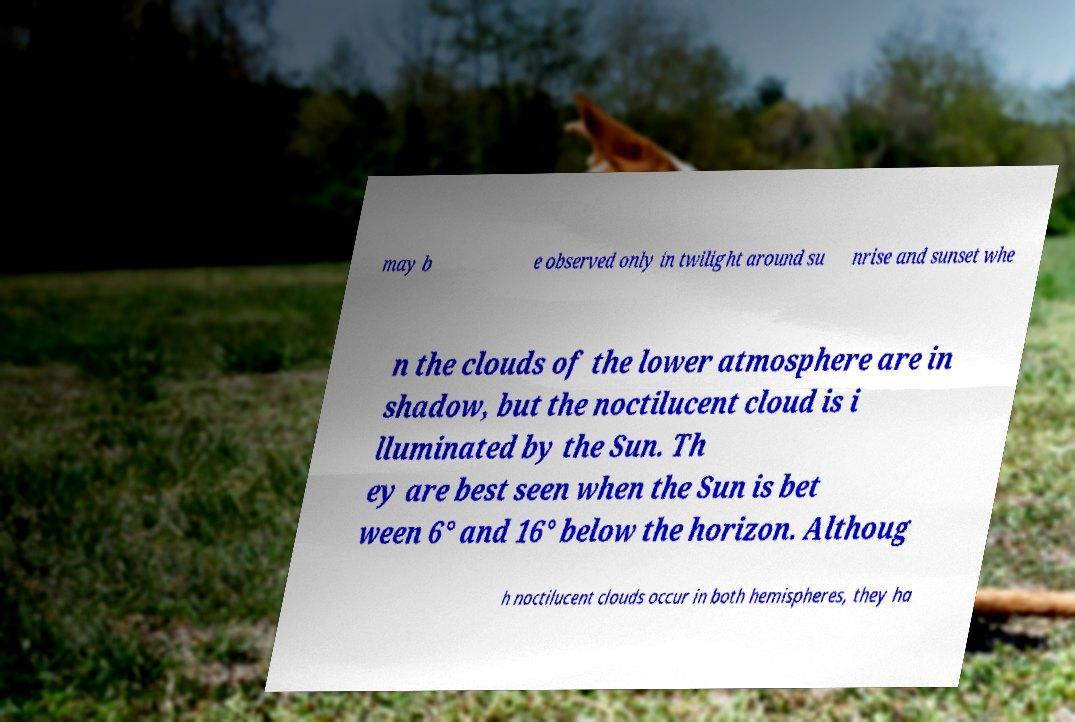There's text embedded in this image that I need extracted. Can you transcribe it verbatim? may b e observed only in twilight around su nrise and sunset whe n the clouds of the lower atmosphere are in shadow, but the noctilucent cloud is i lluminated by the Sun. Th ey are best seen when the Sun is bet ween 6° and 16° below the horizon. Althoug h noctilucent clouds occur in both hemispheres, they ha 